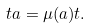Convert formula to latex. <formula><loc_0><loc_0><loc_500><loc_500>t a = \mu ( a ) t .</formula> 